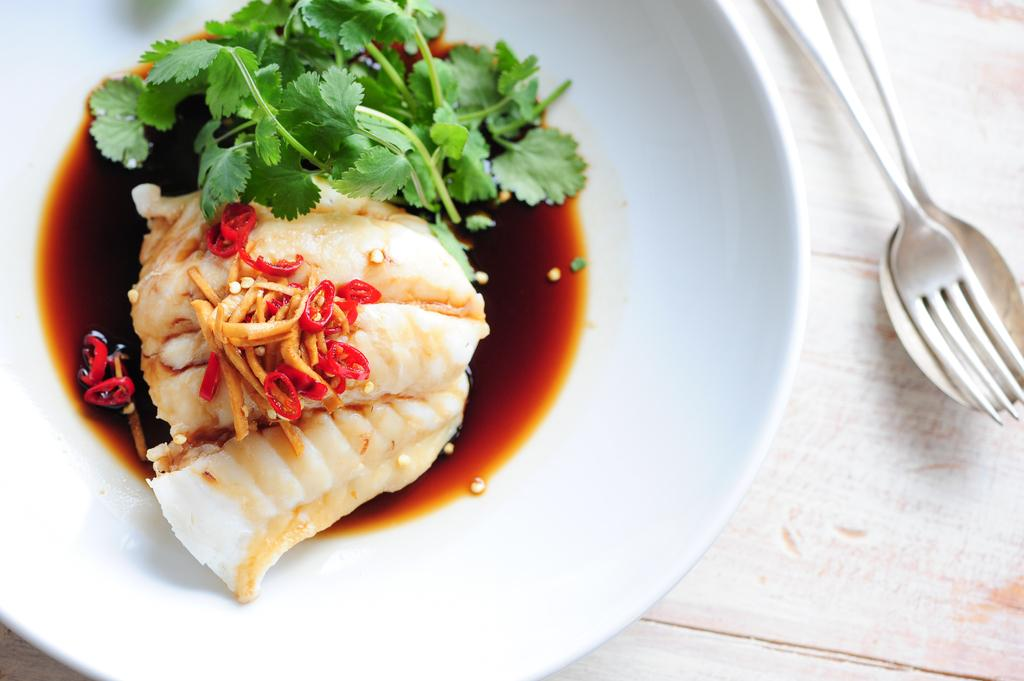What is located beside the plate in the image? There are spoons beside the plate in the image. What is on the plate in the image? The plate contains sauce, coriander, chives, and food. What type of utensils are visible in the image? Spoons are visible in the image. Where is the plate placed in the image? The plate is placed on a table in the image. What musical instrument is being played in the image? There is no musical instrument being played in the image; it only features a plate, spoons, and the table. 